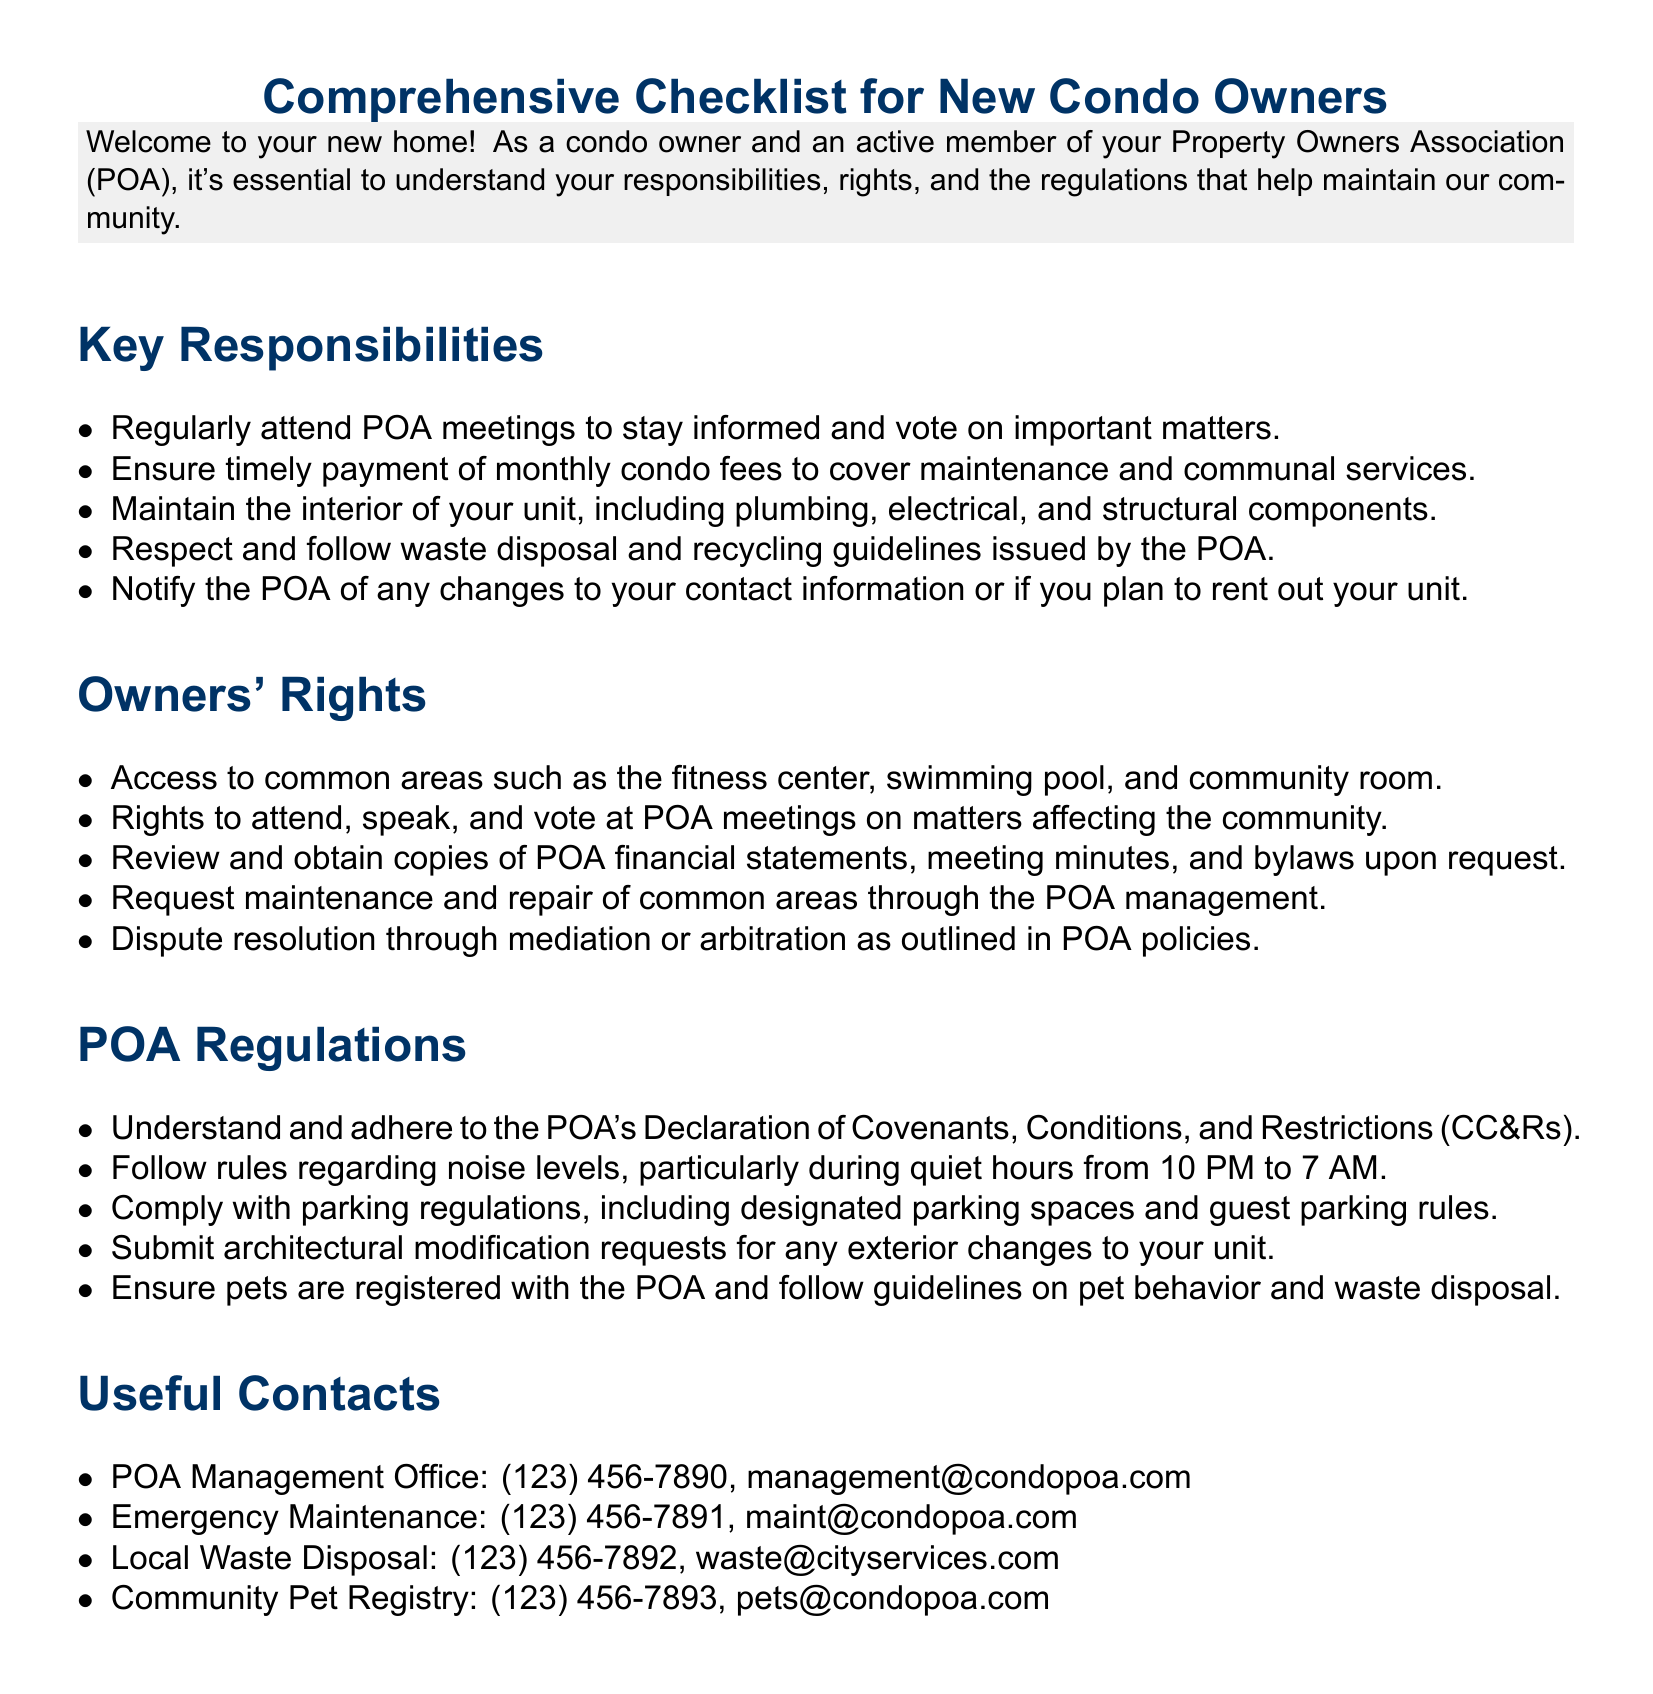What are the key responsibilities of condo owners? The key responsibilities listed are attending POA meetings, timely payment of fees, maintaining the interior of the unit, following waste disposal and recycling guidelines, and notifying the POA of contact changes.
Answer: Attend POA meetings, timely payment of fees, maintain interior, follow waste disposal guidelines, notify POA What hours are considered quiet hours? The document specifies quiet hours during which noise levels must be minimized as 10 PM to 7 AM.
Answer: 10 PM to 7 AM How can owners dispute issues according to POA policies? Owners can pursue dispute resolution through mediation or arbitration as outlined in POA policies, according to the document.
Answer: Mediation or arbitration What telephone number should be used for emergency maintenance? The number provided for emergency maintenance services is listed as (123) 456-7891.
Answer: (123) 456-7891 What is required before making exterior changes to a unit? The document states that owners must submit architectural modification requests for any exterior changes to their unit.
Answer: Submit architectural modification requests What is a key right of condo owners regarding POA meetings? Condo owners have the right to attend, speak, and vote at POA meetings on community matters, as stated in the document.
Answer: Attend, speak, and vote at POA meetings What guidelines must pet owners follow? Pet owners are required to register their pets with the POA and follow specific guidelines on pet behavior and waste disposal.
Answer: Register pets and follow guidelines What are the owners' rights to financial documents? Owners have the right to review and obtain copies of POA financial statements, meeting minutes, and bylaws upon request.
Answer: Review and obtain financial statements, meeting minutes, and bylaws What should condo owners do if they plan to rent their unit? The document emphasizes that owners should notify the POA of any changes, including plans to rent out their unit.
Answer: Notify the POA 